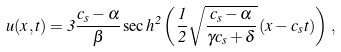<formula> <loc_0><loc_0><loc_500><loc_500>u ( x , t ) = 3 \frac { c _ { s } - \alpha } { \beta } \, { \sec h } ^ { 2 } \left ( \frac { 1 } { 2 } \sqrt { \frac { c _ { s } - \alpha } { \gamma c _ { s } + \delta } } \, ( x - c _ { s } t ) \right ) \, ,</formula> 